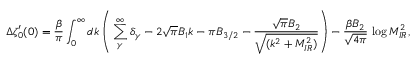<formula> <loc_0><loc_0><loc_500><loc_500>\Delta \zeta _ { 0 } ^ { \prime } ( 0 ) = \frac { \beta } { \pi } \int _ { 0 } ^ { \infty } d k \left ( \, \sum _ { \gamma } ^ { \infty } \delta _ { \gamma } - 2 \sqrt { \pi } B _ { 1 } k - \pi B _ { 3 / 2 } - \frac { \sqrt { \pi } B _ { 2 } } { \sqrt { ( k ^ { 2 } + M _ { I R } ^ { 2 } ) } } \right ) - \frac { \beta B _ { 2 } } { \sqrt { 4 \pi } } \, \log M _ { I R } ^ { 2 } ,</formula> 